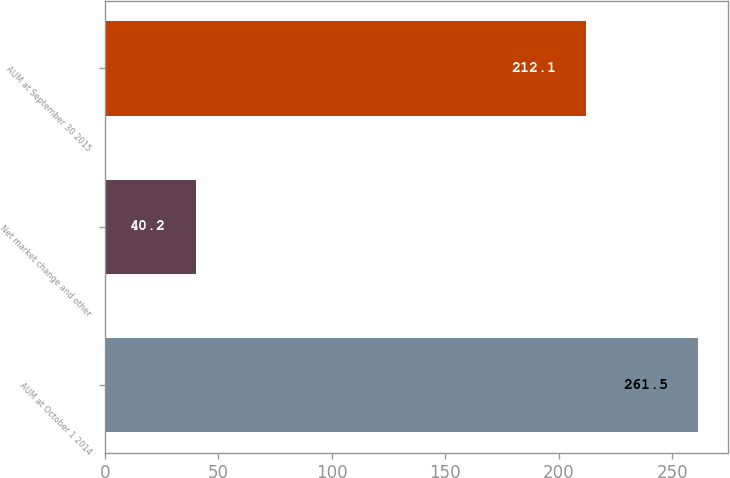Convert chart. <chart><loc_0><loc_0><loc_500><loc_500><bar_chart><fcel>AUM at October 1 2014<fcel>Net market change and other<fcel>AUM at September 30 2015<nl><fcel>261.5<fcel>40.2<fcel>212.1<nl></chart> 